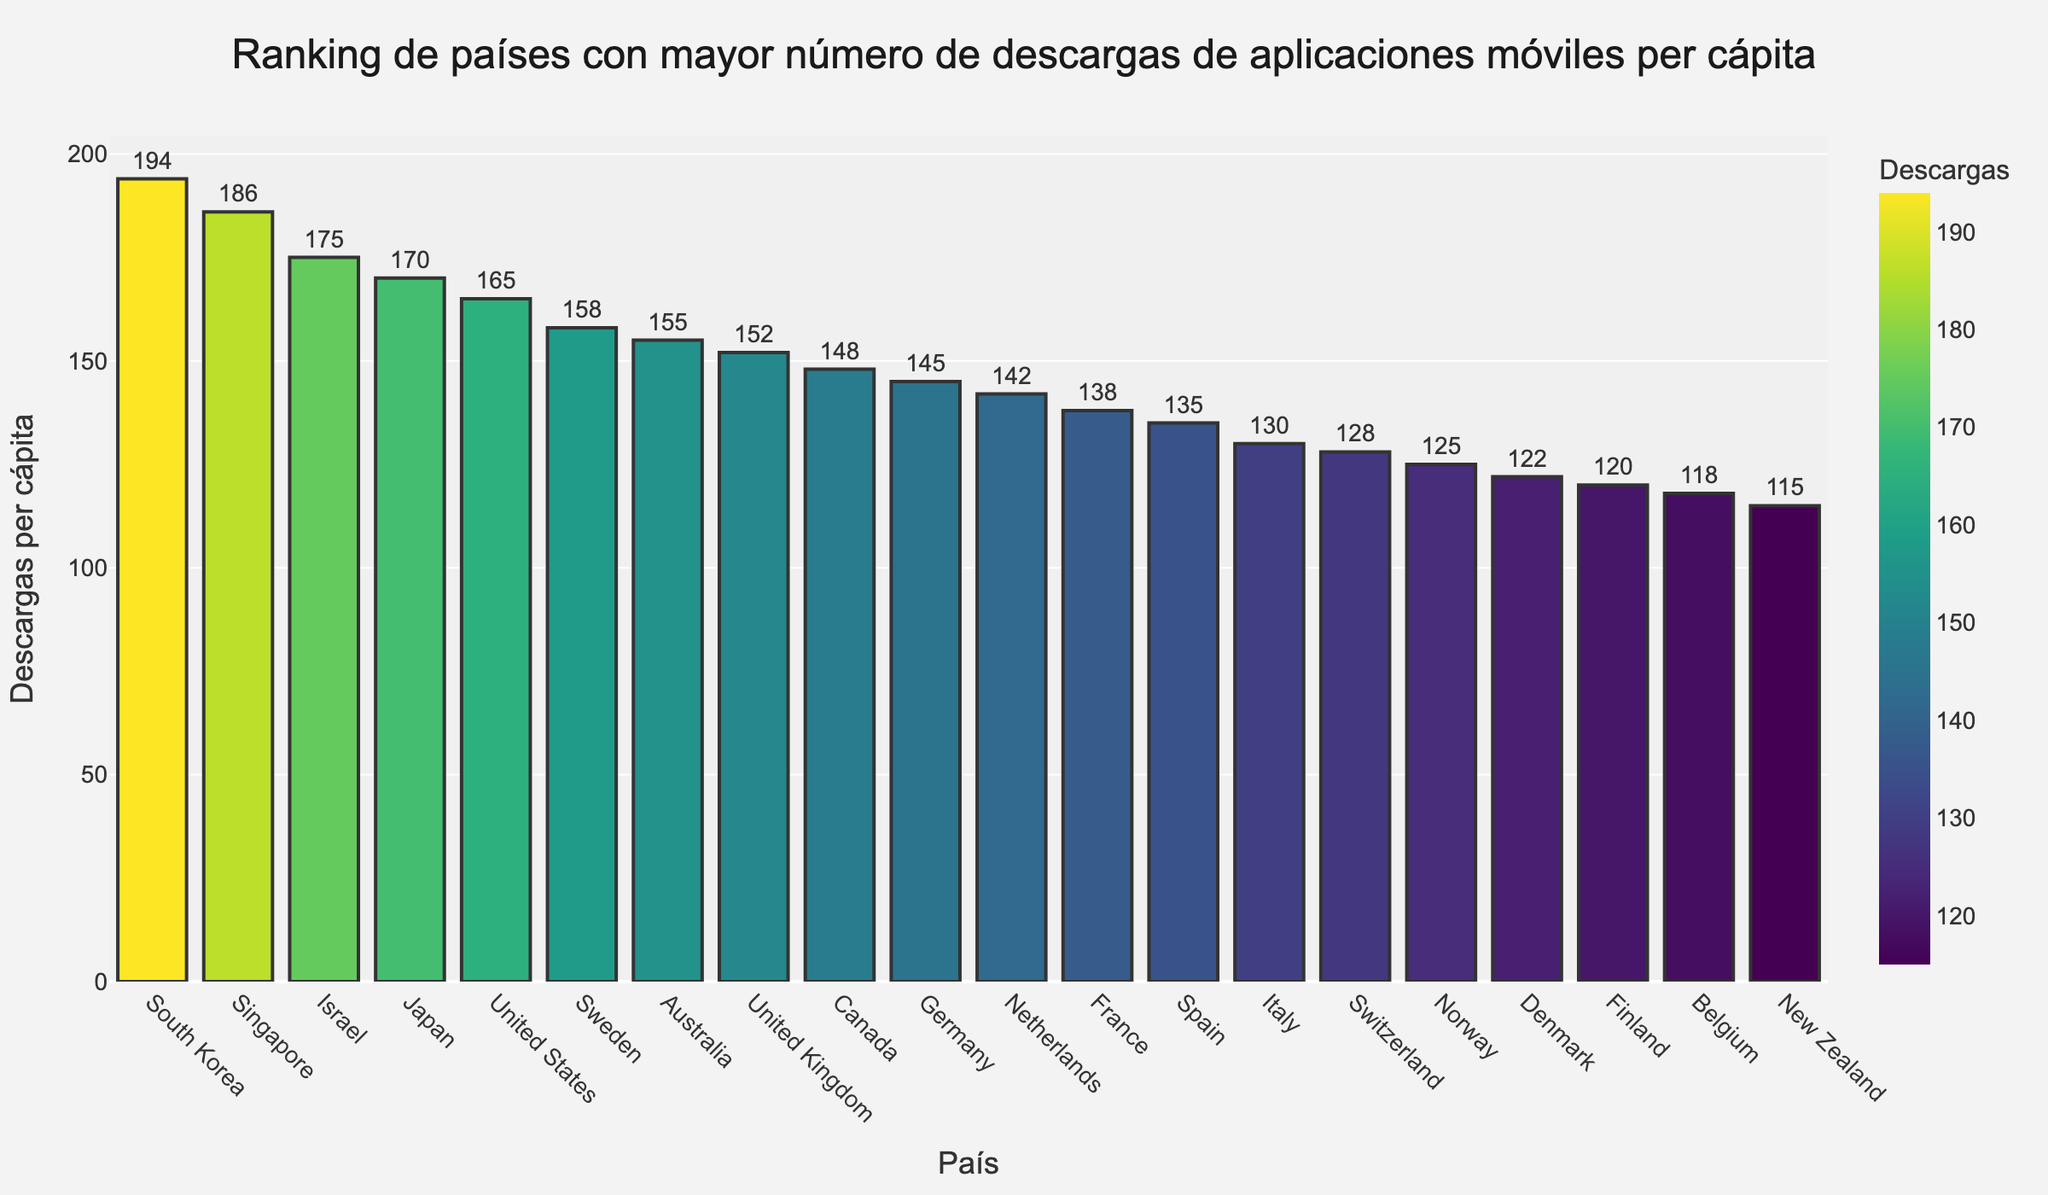What's the country with the highest number of downloads per capita? The bar that represents South Korea is the tallest among all bars, indicating it has the highest number of downloads per capita.
Answer: South Korea Which country has fewer downloads per capita, Norway or Finland? By comparing the heights of the bars representing Norway and Finland, Norway has a taller bar indicating more downloads per capita. Therefore, Finland has fewer downloads per capita.
Answer: Finland What is the difference in downloads per capita between Japan and the United States? The bar for Japan shows 170 downloads per capita, and the bar for the United States shows 165 downloads per capita. The difference is 170 - 165.
Answer: 5 Which country ranks higher in downloads per capita, Australia or Sweden? Comparing the heights of the bars, Sweden's bar is taller than Australia's bar, indicating Sweden ranks higher in downloads per capita.
Answer: Sweden What is the combined downloads per capita for Canada and Germany? The bar for Canada indicates 148 downloads per capita and the bar for Germany indicates 145. Combined, it is 148 + 145.
Answer: 293 How many countries have more than 150 downloads per capita? By counting the bars which heights exceed the value of 150 downloads per capita, there are five countries: South Korea, Singapore, Israel, Japan, and the United States.
Answer: 5 Which of the countries among United Kingdom and France has a higher number of downloads per capita? The bar for the United Kingdom shows 152 downloads per capita, and the bar for France shows 138. The United Kingdom has a higher number of downloads per capita.
Answer: United Kingdom What is the position of Spain in the ranking? Observing the descending order of bar heights, Spain's bar is the 13th tallest.
Answer: 13th What is the average number of downloads per capita for the top three countries? The top three countries with the highest downloads per capita are South Korea (194), Singapore (186), and Israel (175). The average is calculated as (194 + 186 + 175) / 3.
Answer: 185 Which countries have a similar number of downloads per capita, close to 145? By observing the bars, Germany, with 145 downloads per capita, and the Netherlands, with 142, have similar download numbers per capita.
Answer: Germany, Netherlands 